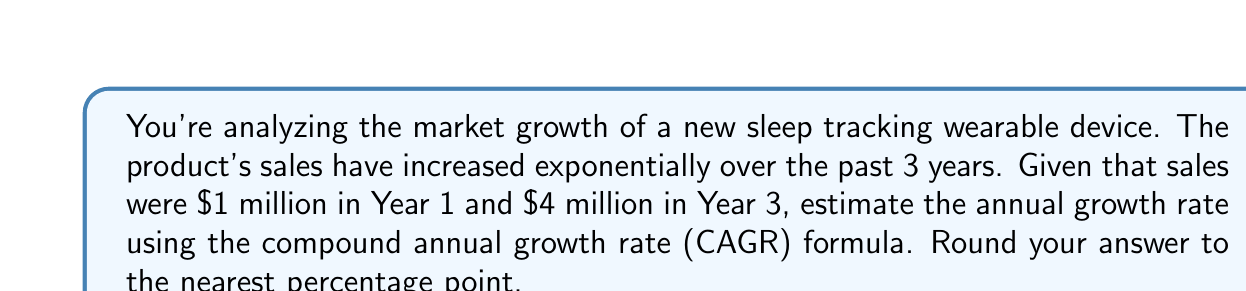Show me your answer to this math problem. To solve this problem, we'll use the Compound Annual Growth Rate (CAGR) formula:

$$ CAGR = \left(\frac{Ending Value}{Beginning Value}\right)^{\frac{1}{n}} - 1 $$

Where:
- Ending Value = $4 million (Year 3 sales)
- Beginning Value = $1 million (Year 1 sales)
- n = 2 (number of years between Year 1 and Year 3)

Let's substitute these values into the formula:

$$ CAGR = \left(\frac{4}{1}\right)^{\frac{1}{2}} - 1 $$

Now, let's solve step-by-step:

1) First, calculate the fraction inside the parentheses:
   $\frac{4}{1} = 4$

2) Now, we have:
   $$ CAGR = (4)^{\frac{1}{2}} - 1 $$

3) Calculate the square root of 4:
   $\sqrt{4} = 2$

4) Our equation is now:
   $$ CAGR = 2 - 1 = 1 $$

5) Convert to a percentage:
   $1 * 100\% = 100\%$

Therefore, the estimated annual growth rate is 100%.
Answer: 100% 